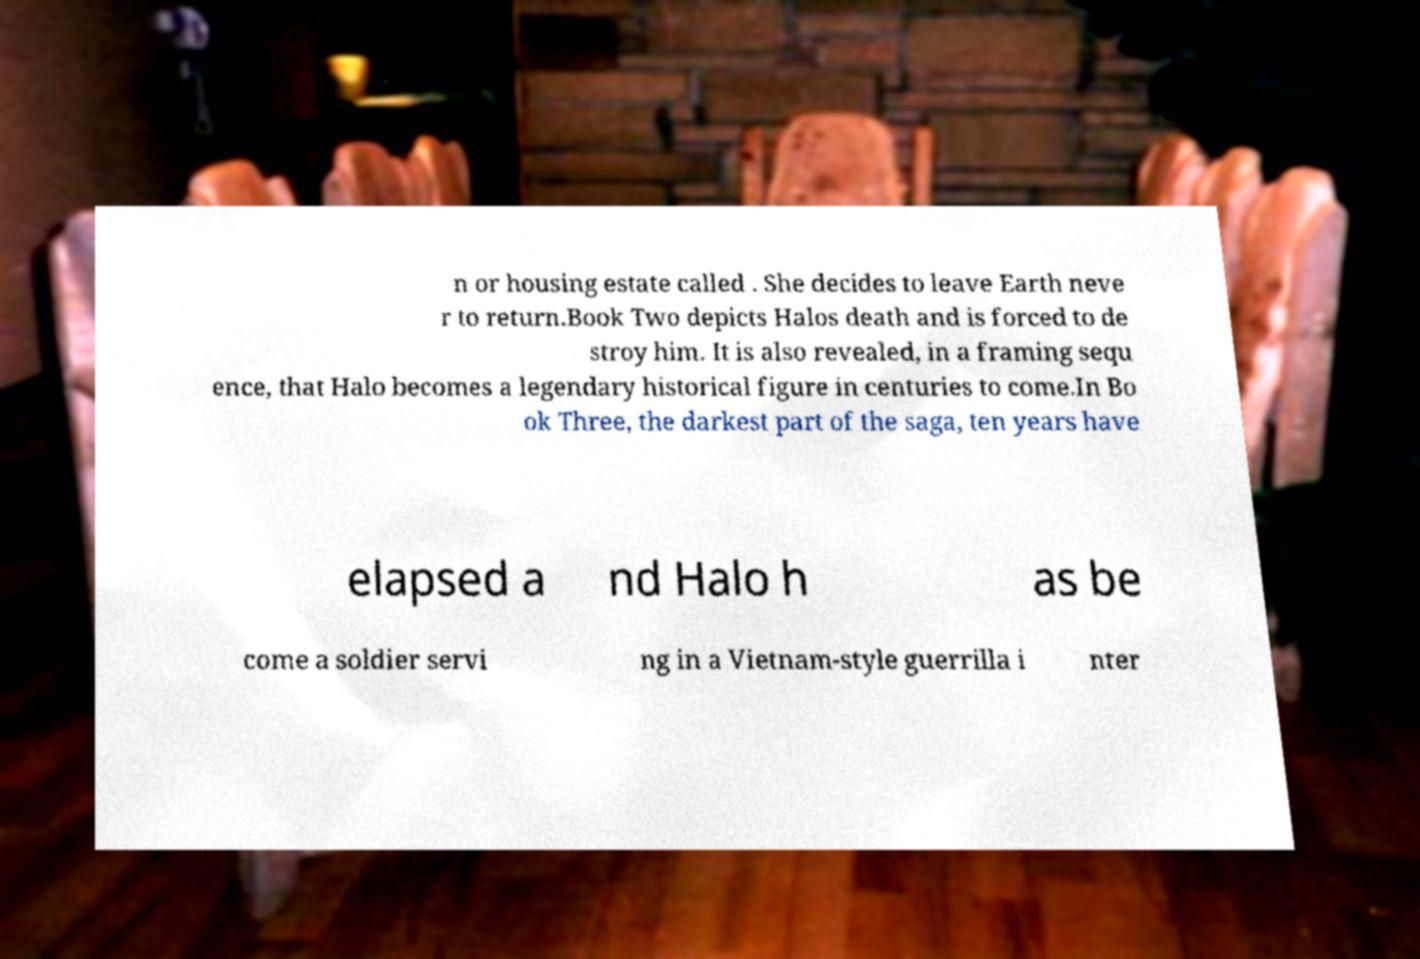Can you accurately transcribe the text from the provided image for me? n or housing estate called . She decides to leave Earth neve r to return.Book Two depicts Halos death and is forced to de stroy him. It is also revealed, in a framing sequ ence, that Halo becomes a legendary historical figure in centuries to come.In Bo ok Three, the darkest part of the saga, ten years have elapsed a nd Halo h as be come a soldier servi ng in a Vietnam-style guerrilla i nter 